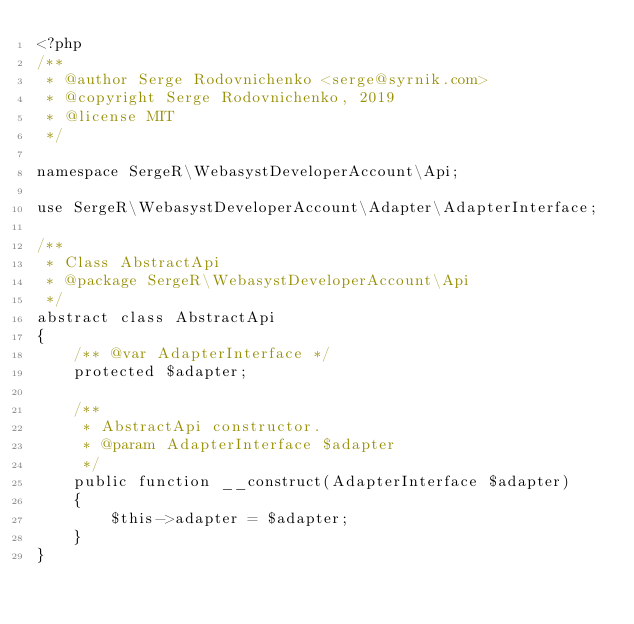<code> <loc_0><loc_0><loc_500><loc_500><_PHP_><?php
/**
 * @author Serge Rodovnichenko <serge@syrnik.com>
 * @copyright Serge Rodovnichenko, 2019
 * @license MIT
 */

namespace SergeR\WebasystDeveloperAccount\Api;

use SergeR\WebasystDeveloperAccount\Adapter\AdapterInterface;

/**
 * Class AbstractApi
 * @package SergeR\WebasystDeveloperAccount\Api
 */
abstract class AbstractApi
{
    /** @var AdapterInterface */
    protected $adapter;

    /**
     * AbstractApi constructor.
     * @param AdapterInterface $adapter
     */
    public function __construct(AdapterInterface $adapter)
    {
        $this->adapter = $adapter;
    }
}</code> 